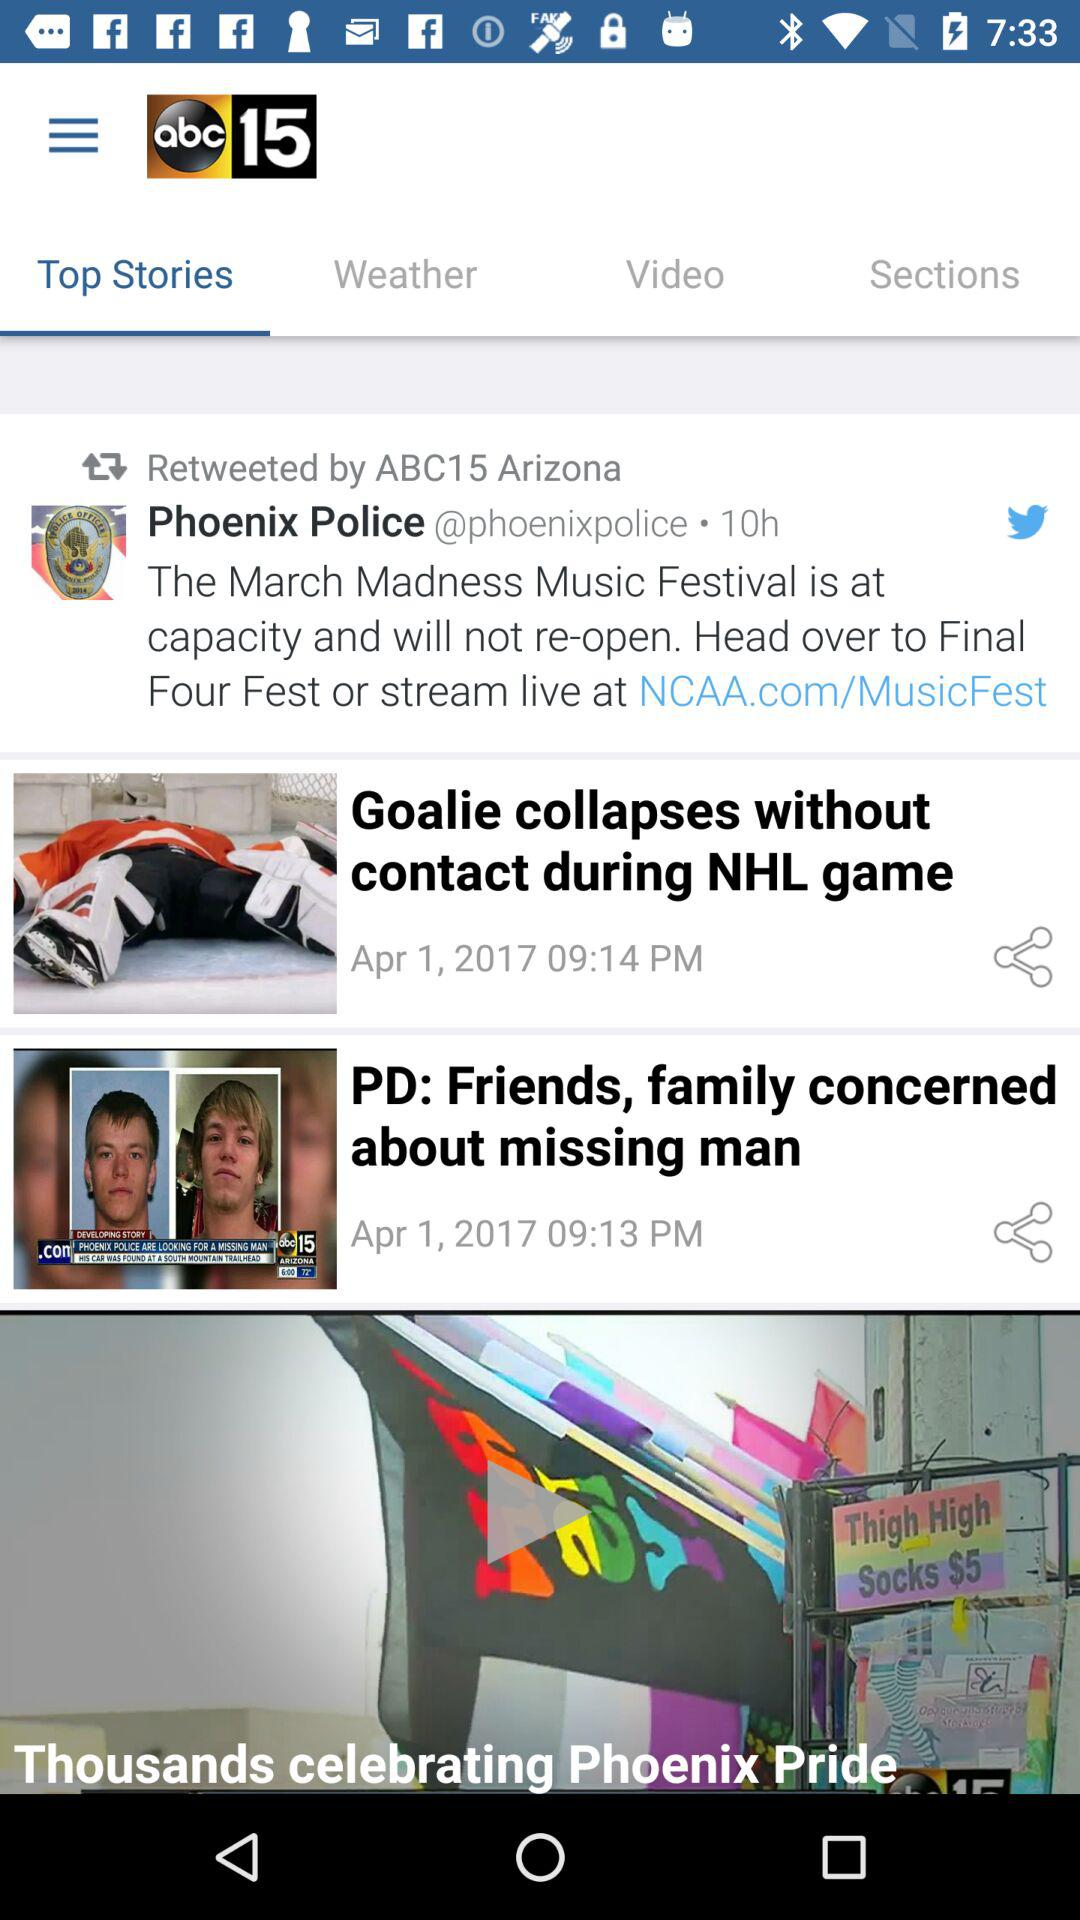At what time was the story "Goalie collapses without contact during NHL game" posted? The story "Goalie collapses without contact during NHL game" was posted at 09:14 PM. 